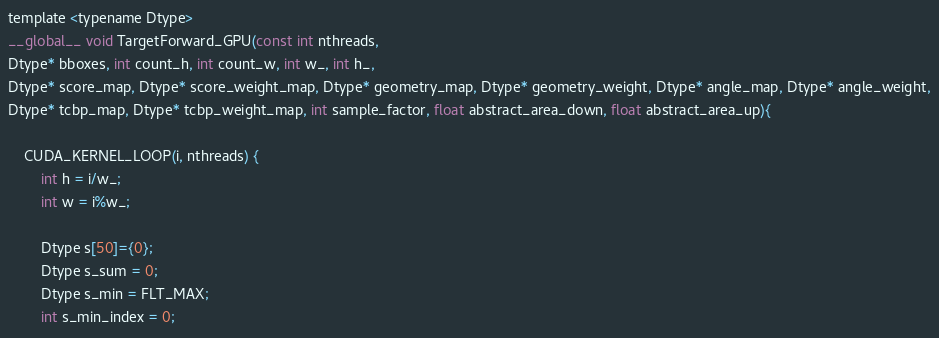<code> <loc_0><loc_0><loc_500><loc_500><_Cuda_>
template <typename Dtype>
__global__ void TargetForward_GPU(const int nthreads,
Dtype* bboxes, int count_h, int count_w, int w_, int h_,
Dtype* score_map, Dtype* score_weight_map, Dtype* geometry_map, Dtype* geometry_weight, Dtype* angle_map, Dtype* angle_weight,
Dtype* tcbp_map, Dtype* tcbp_weight_map, int sample_factor, float abstract_area_down, float abstract_area_up){

	CUDA_KERNEL_LOOP(i, nthreads) {
		int h = i/w_;
		int w = i%w_;

		Dtype s[50]={0};
		Dtype s_sum = 0;
		Dtype s_min = FLT_MAX;
		int s_min_index = 0;</code> 